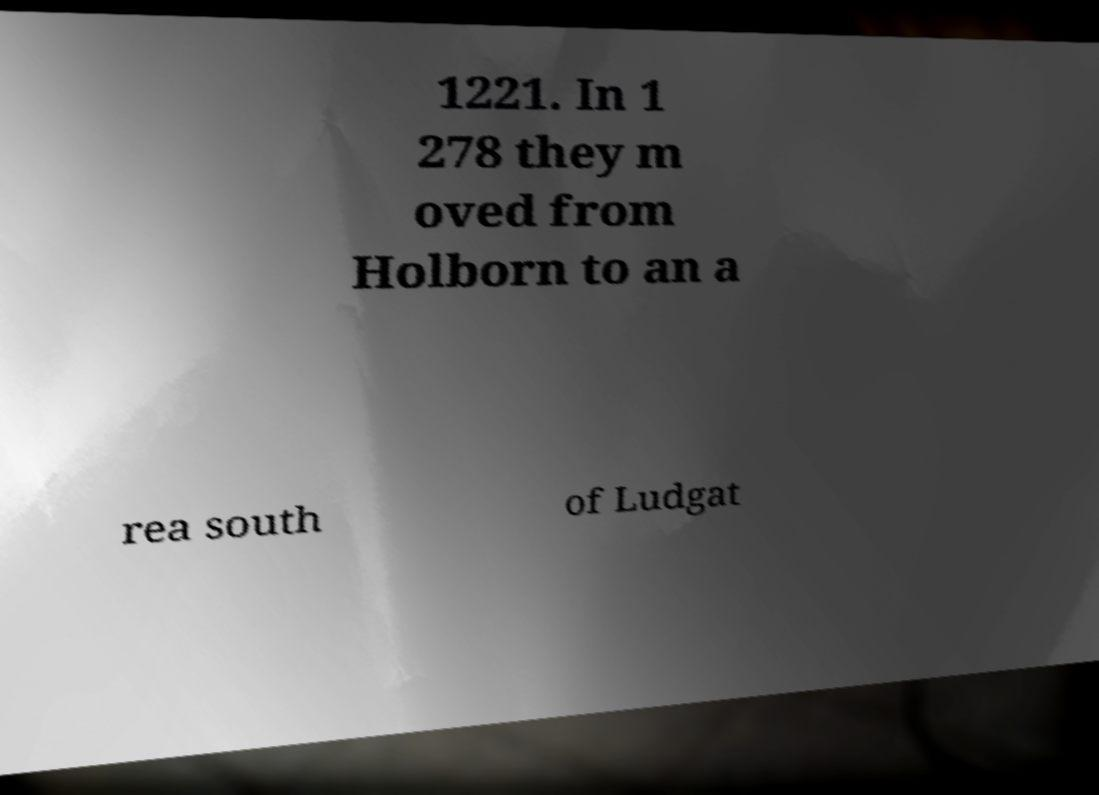For documentation purposes, I need the text within this image transcribed. Could you provide that? 1221. In 1 278 they m oved from Holborn to an a rea south of Ludgat 